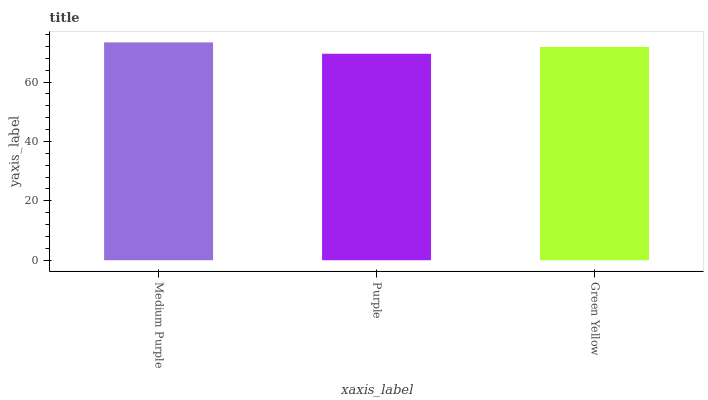Is Purple the minimum?
Answer yes or no. Yes. Is Medium Purple the maximum?
Answer yes or no. Yes. Is Green Yellow the minimum?
Answer yes or no. No. Is Green Yellow the maximum?
Answer yes or no. No. Is Green Yellow greater than Purple?
Answer yes or no. Yes. Is Purple less than Green Yellow?
Answer yes or no. Yes. Is Purple greater than Green Yellow?
Answer yes or no. No. Is Green Yellow less than Purple?
Answer yes or no. No. Is Green Yellow the high median?
Answer yes or no. Yes. Is Green Yellow the low median?
Answer yes or no. Yes. Is Purple the high median?
Answer yes or no. No. Is Purple the low median?
Answer yes or no. No. 